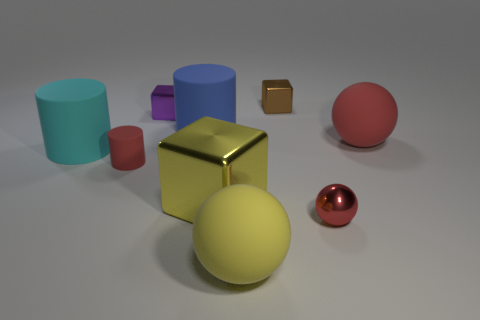Subtract 1 blocks. How many blocks are left? 2 Subtract all large cylinders. How many cylinders are left? 1 Add 1 large objects. How many objects exist? 10 Subtract all brown balls. Subtract all purple cylinders. How many balls are left? 3 Subtract all spheres. How many objects are left? 6 Subtract all big purple matte balls. Subtract all large red objects. How many objects are left? 8 Add 8 large yellow shiny cubes. How many large yellow shiny cubes are left? 9 Add 7 purple metallic blocks. How many purple metallic blocks exist? 8 Subtract 0 brown cylinders. How many objects are left? 9 